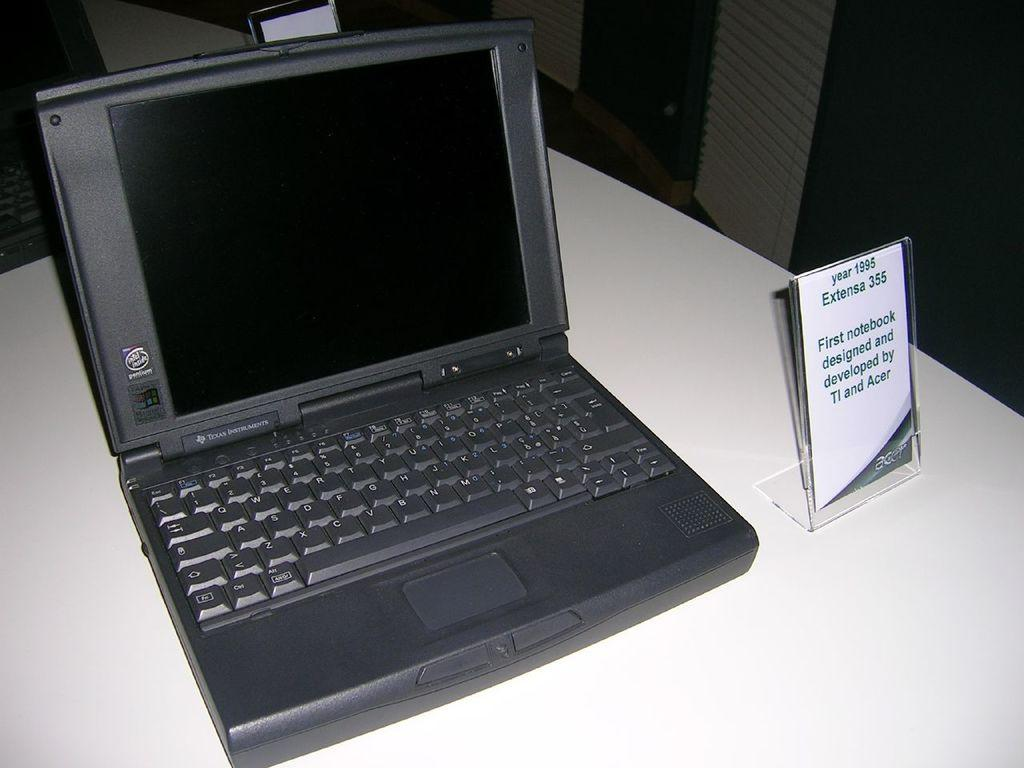What electronic device is visible in the image? There is a laptop in the image. What other object can be seen in the image? There is a nameplate in the image. On what surface is the nameplate placed? The nameplate is on a white surface. How many clocks are visible on the laptop in the image? There are no clocks visible on the laptop in the image. What type of governor is mentioned on the nameplate in the image? There is no governor mentioned on the nameplate in the image. 